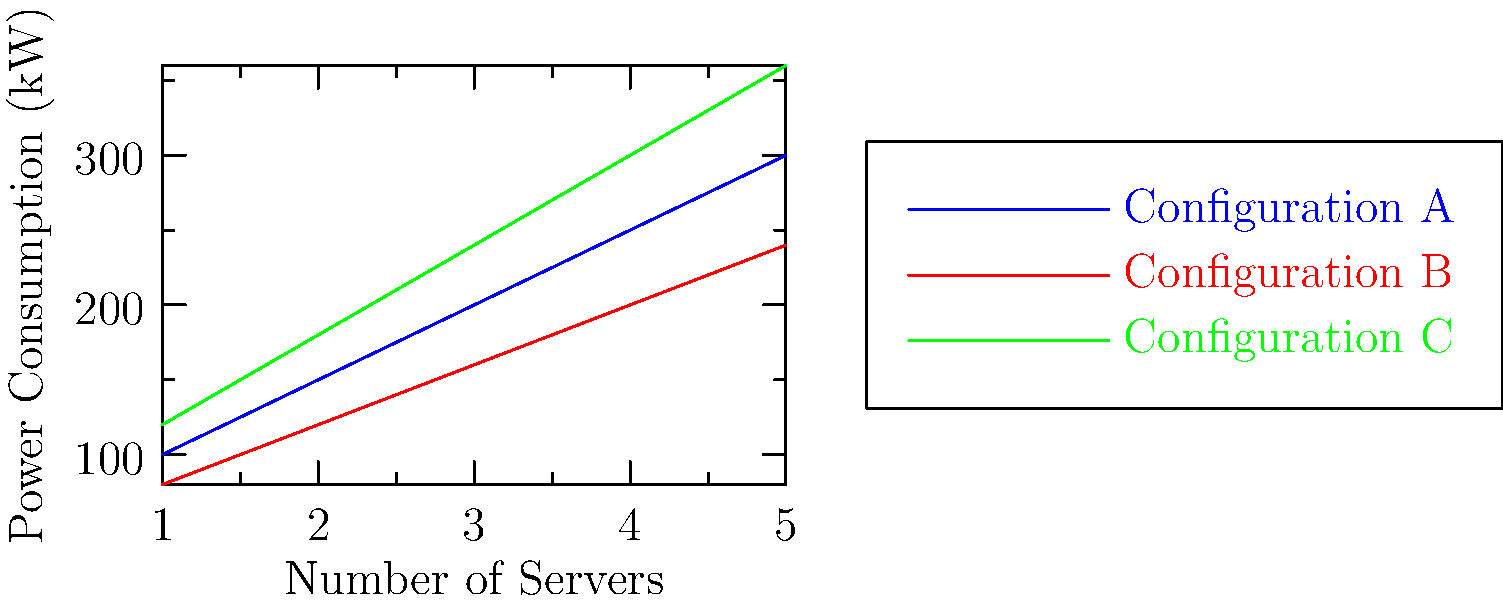Based on the power consumption analysis graph for various server configurations, which configuration would be most suitable for a company aiming to expand its data center capacity while minimizing energy costs? Assume that all configurations meet the required performance standards. To determine the most suitable configuration for expanding data center capacity while minimizing energy costs, we need to analyze the power consumption trends for each configuration:

1. Examine the graph:
   - Configuration A (blue line): Starts at 100 kW for 1 server and increases to 300 kW for 5 servers.
   - Configuration B (red line): Starts at 80 kW for 1 server and increases to 240 kW for 5 servers.
   - Configuration C (green line): Starts at 120 kW for 1 server and increases to 360 kW for 5 servers.

2. Calculate the rate of increase in power consumption:
   - Configuration A: (300 kW - 100 kW) / 4 = 50 kW per additional server
   - Configuration B: (240 kW - 80 kW) / 4 = 40 kW per additional server
   - Configuration C: (360 kW - 120 kW) / 4 = 60 kW per additional server

3. Compare energy efficiency:
   - Configuration B has the lowest starting point (80 kW) and the slowest rate of increase (40 kW per server).
   - Configuration A has a moderate starting point and rate of increase.
   - Configuration C has the highest starting point and fastest rate of increase.

4. Consider scalability:
   - As the number of servers increases, the gap in power consumption between Configuration B and the others widens, indicating better long-term energy efficiency.

Given that all configurations meet the required performance standards, Configuration B would be the most suitable for expanding data center capacity while minimizing energy costs. It consistently consumes less power across all server quantities and has the slowest rate of increase in power consumption as the number of servers grows.
Answer: Configuration B 